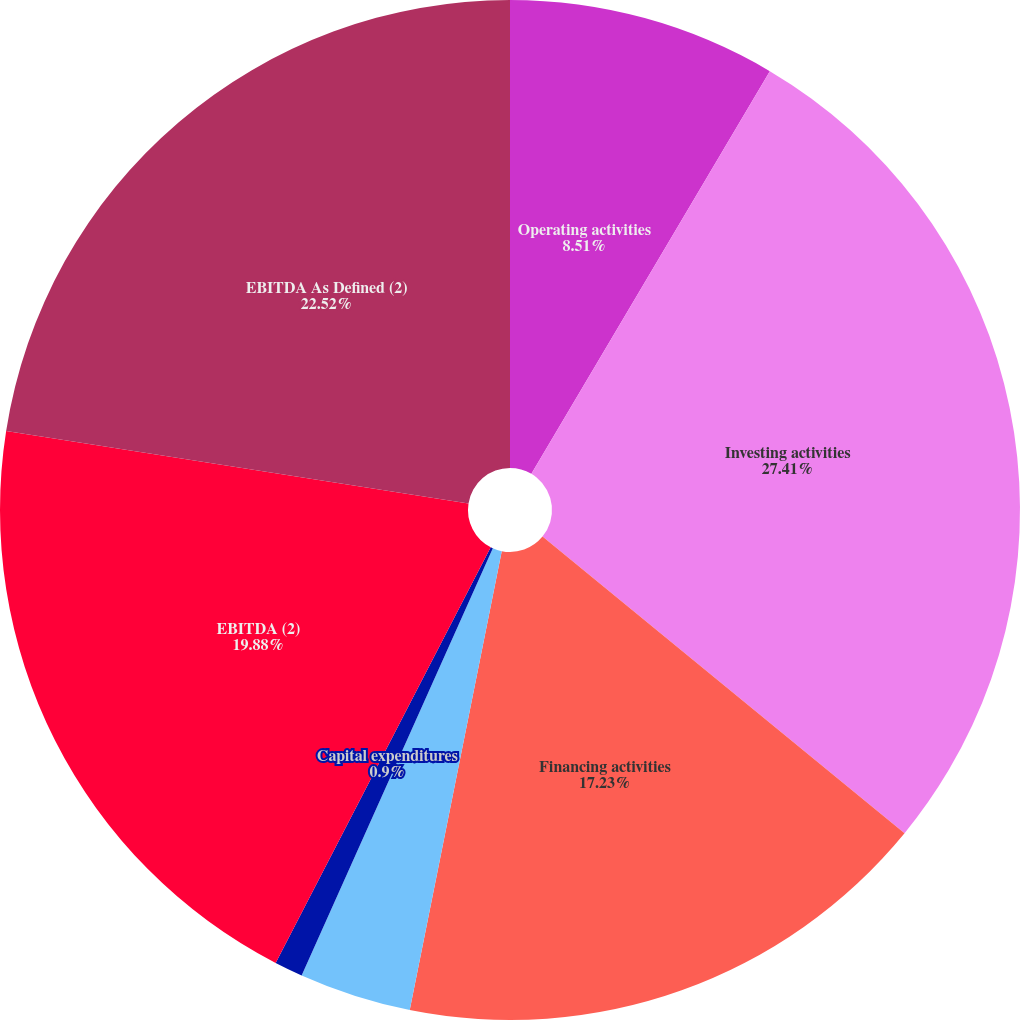Convert chart to OTSL. <chart><loc_0><loc_0><loc_500><loc_500><pie_chart><fcel>Operating activities<fcel>Investing activities<fcel>Financing activities<fcel>Depreciation and amortization<fcel>Capital expenditures<fcel>EBITDA (2)<fcel>EBITDA As Defined (2)<nl><fcel>8.51%<fcel>27.42%<fcel>17.23%<fcel>3.55%<fcel>0.9%<fcel>19.88%<fcel>22.53%<nl></chart> 